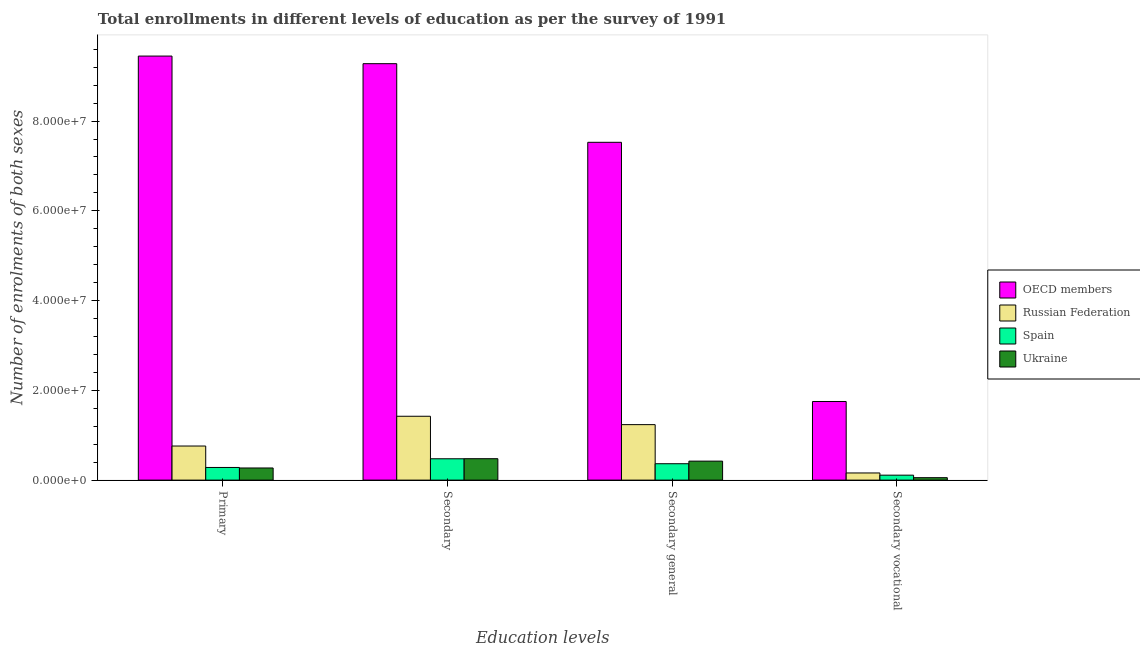Are the number of bars on each tick of the X-axis equal?
Make the answer very short. Yes. What is the label of the 3rd group of bars from the left?
Provide a short and direct response. Secondary general. What is the number of enrolments in secondary education in Ukraine?
Ensure brevity in your answer.  4.77e+06. Across all countries, what is the maximum number of enrolments in secondary general education?
Your answer should be very brief. 7.53e+07. Across all countries, what is the minimum number of enrolments in primary education?
Give a very brief answer. 2.70e+06. What is the total number of enrolments in primary education in the graph?
Make the answer very short. 1.08e+08. What is the difference between the number of enrolments in secondary education in Spain and that in Ukraine?
Your answer should be very brief. -1.84e+04. What is the difference between the number of enrolments in secondary education in Spain and the number of enrolments in secondary vocational education in Russian Federation?
Give a very brief answer. 3.16e+06. What is the average number of enrolments in secondary vocational education per country?
Provide a succinct answer. 5.19e+06. What is the difference between the number of enrolments in secondary general education and number of enrolments in secondary education in Russian Federation?
Your response must be concise. -1.87e+06. What is the ratio of the number of enrolments in secondary education in Ukraine to that in OECD members?
Your response must be concise. 0.05. Is the number of enrolments in primary education in Russian Federation less than that in OECD members?
Ensure brevity in your answer.  Yes. What is the difference between the highest and the second highest number of enrolments in secondary vocational education?
Your response must be concise. 1.59e+07. What is the difference between the highest and the lowest number of enrolments in secondary general education?
Ensure brevity in your answer.  7.16e+07. Is it the case that in every country, the sum of the number of enrolments in secondary general education and number of enrolments in secondary vocational education is greater than the sum of number of enrolments in secondary education and number of enrolments in primary education?
Offer a terse response. No. What does the 3rd bar from the left in Secondary general represents?
Offer a terse response. Spain. What does the 3rd bar from the right in Secondary vocational represents?
Keep it short and to the point. Russian Federation. Is it the case that in every country, the sum of the number of enrolments in primary education and number of enrolments in secondary education is greater than the number of enrolments in secondary general education?
Your answer should be very brief. Yes. How many bars are there?
Make the answer very short. 16. Are all the bars in the graph horizontal?
Give a very brief answer. No. How many countries are there in the graph?
Your answer should be compact. 4. What is the difference between two consecutive major ticks on the Y-axis?
Your answer should be compact. 2.00e+07. Are the values on the major ticks of Y-axis written in scientific E-notation?
Ensure brevity in your answer.  Yes. How are the legend labels stacked?
Offer a very short reply. Vertical. What is the title of the graph?
Your response must be concise. Total enrollments in different levels of education as per the survey of 1991. What is the label or title of the X-axis?
Your answer should be compact. Education levels. What is the label or title of the Y-axis?
Ensure brevity in your answer.  Number of enrolments of both sexes. What is the Number of enrolments of both sexes of OECD members in Primary?
Give a very brief answer. 9.45e+07. What is the Number of enrolments of both sexes of Russian Federation in Primary?
Make the answer very short. 7.60e+06. What is the Number of enrolments of both sexes in Spain in Primary?
Your response must be concise. 2.82e+06. What is the Number of enrolments of both sexes in Ukraine in Primary?
Give a very brief answer. 2.70e+06. What is the Number of enrolments of both sexes in OECD members in Secondary?
Give a very brief answer. 9.28e+07. What is the Number of enrolments of both sexes in Russian Federation in Secondary?
Offer a very short reply. 1.42e+07. What is the Number of enrolments of both sexes of Spain in Secondary?
Your response must be concise. 4.76e+06. What is the Number of enrolments of both sexes of Ukraine in Secondary?
Make the answer very short. 4.77e+06. What is the Number of enrolments of both sexes of OECD members in Secondary general?
Ensure brevity in your answer.  7.53e+07. What is the Number of enrolments of both sexes of Russian Federation in Secondary general?
Offer a terse response. 1.24e+07. What is the Number of enrolments of both sexes in Spain in Secondary general?
Your answer should be compact. 3.65e+06. What is the Number of enrolments of both sexes in Ukraine in Secondary general?
Ensure brevity in your answer.  4.23e+06. What is the Number of enrolments of both sexes of OECD members in Secondary vocational?
Your answer should be very brief. 1.75e+07. What is the Number of enrolments of both sexes in Russian Federation in Secondary vocational?
Provide a succinct answer. 1.59e+06. What is the Number of enrolments of both sexes in Spain in Secondary vocational?
Your answer should be very brief. 1.10e+06. What is the Number of enrolments of both sexes of Ukraine in Secondary vocational?
Offer a terse response. 5.44e+05. Across all Education levels, what is the maximum Number of enrolments of both sexes in OECD members?
Provide a short and direct response. 9.45e+07. Across all Education levels, what is the maximum Number of enrolments of both sexes of Russian Federation?
Provide a short and direct response. 1.42e+07. Across all Education levels, what is the maximum Number of enrolments of both sexes of Spain?
Give a very brief answer. 4.76e+06. Across all Education levels, what is the maximum Number of enrolments of both sexes in Ukraine?
Make the answer very short. 4.77e+06. Across all Education levels, what is the minimum Number of enrolments of both sexes in OECD members?
Give a very brief answer. 1.75e+07. Across all Education levels, what is the minimum Number of enrolments of both sexes of Russian Federation?
Provide a succinct answer. 1.59e+06. Across all Education levels, what is the minimum Number of enrolments of both sexes in Spain?
Provide a short and direct response. 1.10e+06. Across all Education levels, what is the minimum Number of enrolments of both sexes in Ukraine?
Make the answer very short. 5.44e+05. What is the total Number of enrolments of both sexes of OECD members in the graph?
Your answer should be compact. 2.80e+08. What is the total Number of enrolments of both sexes in Russian Federation in the graph?
Your answer should be compact. 3.58e+07. What is the total Number of enrolments of both sexes in Spain in the graph?
Offer a very short reply. 1.23e+07. What is the total Number of enrolments of both sexes in Ukraine in the graph?
Give a very brief answer. 1.23e+07. What is the difference between the Number of enrolments of both sexes in OECD members in Primary and that in Secondary?
Provide a succinct answer. 1.69e+06. What is the difference between the Number of enrolments of both sexes of Russian Federation in Primary and that in Secondary?
Give a very brief answer. -6.63e+06. What is the difference between the Number of enrolments of both sexes in Spain in Primary and that in Secondary?
Provide a short and direct response. -1.93e+06. What is the difference between the Number of enrolments of both sexes in Ukraine in Primary and that in Secondary?
Offer a very short reply. -2.07e+06. What is the difference between the Number of enrolments of both sexes in OECD members in Primary and that in Secondary general?
Provide a succinct answer. 1.92e+07. What is the difference between the Number of enrolments of both sexes in Russian Federation in Primary and that in Secondary general?
Offer a very short reply. -4.77e+06. What is the difference between the Number of enrolments of both sexes of Spain in Primary and that in Secondary general?
Provide a succinct answer. -8.33e+05. What is the difference between the Number of enrolments of both sexes in Ukraine in Primary and that in Secondary general?
Ensure brevity in your answer.  -1.53e+06. What is the difference between the Number of enrolments of both sexes in OECD members in Primary and that in Secondary vocational?
Keep it short and to the point. 7.70e+07. What is the difference between the Number of enrolments of both sexes in Russian Federation in Primary and that in Secondary vocational?
Provide a succinct answer. 6.00e+06. What is the difference between the Number of enrolments of both sexes in Spain in Primary and that in Secondary vocational?
Give a very brief answer. 1.72e+06. What is the difference between the Number of enrolments of both sexes in Ukraine in Primary and that in Secondary vocational?
Make the answer very short. 2.16e+06. What is the difference between the Number of enrolments of both sexes in OECD members in Secondary and that in Secondary general?
Your answer should be compact. 1.75e+07. What is the difference between the Number of enrolments of both sexes in Russian Federation in Secondary and that in Secondary general?
Offer a very short reply. 1.87e+06. What is the difference between the Number of enrolments of both sexes of Spain in Secondary and that in Secondary general?
Your answer should be compact. 1.10e+06. What is the difference between the Number of enrolments of both sexes of Ukraine in Secondary and that in Secondary general?
Make the answer very short. 5.44e+05. What is the difference between the Number of enrolments of both sexes of OECD members in Secondary and that in Secondary vocational?
Make the answer very short. 7.53e+07. What is the difference between the Number of enrolments of both sexes in Russian Federation in Secondary and that in Secondary vocational?
Provide a short and direct response. 1.26e+07. What is the difference between the Number of enrolments of both sexes in Spain in Secondary and that in Secondary vocational?
Ensure brevity in your answer.  3.65e+06. What is the difference between the Number of enrolments of both sexes in Ukraine in Secondary and that in Secondary vocational?
Offer a terse response. 4.23e+06. What is the difference between the Number of enrolments of both sexes in OECD members in Secondary general and that in Secondary vocational?
Ensure brevity in your answer.  5.77e+07. What is the difference between the Number of enrolments of both sexes of Russian Federation in Secondary general and that in Secondary vocational?
Keep it short and to the point. 1.08e+07. What is the difference between the Number of enrolments of both sexes in Spain in Secondary general and that in Secondary vocational?
Your response must be concise. 2.55e+06. What is the difference between the Number of enrolments of both sexes in Ukraine in Secondary general and that in Secondary vocational?
Give a very brief answer. 3.69e+06. What is the difference between the Number of enrolments of both sexes in OECD members in Primary and the Number of enrolments of both sexes in Russian Federation in Secondary?
Ensure brevity in your answer.  8.03e+07. What is the difference between the Number of enrolments of both sexes of OECD members in Primary and the Number of enrolments of both sexes of Spain in Secondary?
Your response must be concise. 8.97e+07. What is the difference between the Number of enrolments of both sexes of OECD members in Primary and the Number of enrolments of both sexes of Ukraine in Secondary?
Make the answer very short. 8.97e+07. What is the difference between the Number of enrolments of both sexes of Russian Federation in Primary and the Number of enrolments of both sexes of Spain in Secondary?
Offer a terse response. 2.84e+06. What is the difference between the Number of enrolments of both sexes in Russian Federation in Primary and the Number of enrolments of both sexes in Ukraine in Secondary?
Your response must be concise. 2.82e+06. What is the difference between the Number of enrolments of both sexes of Spain in Primary and the Number of enrolments of both sexes of Ukraine in Secondary?
Give a very brief answer. -1.95e+06. What is the difference between the Number of enrolments of both sexes in OECD members in Primary and the Number of enrolments of both sexes in Russian Federation in Secondary general?
Keep it short and to the point. 8.21e+07. What is the difference between the Number of enrolments of both sexes of OECD members in Primary and the Number of enrolments of both sexes of Spain in Secondary general?
Ensure brevity in your answer.  9.08e+07. What is the difference between the Number of enrolments of both sexes in OECD members in Primary and the Number of enrolments of both sexes in Ukraine in Secondary general?
Ensure brevity in your answer.  9.03e+07. What is the difference between the Number of enrolments of both sexes of Russian Federation in Primary and the Number of enrolments of both sexes of Spain in Secondary general?
Your answer should be very brief. 3.94e+06. What is the difference between the Number of enrolments of both sexes of Russian Federation in Primary and the Number of enrolments of both sexes of Ukraine in Secondary general?
Offer a very short reply. 3.37e+06. What is the difference between the Number of enrolments of both sexes of Spain in Primary and the Number of enrolments of both sexes of Ukraine in Secondary general?
Offer a very short reply. -1.41e+06. What is the difference between the Number of enrolments of both sexes in OECD members in Primary and the Number of enrolments of both sexes in Russian Federation in Secondary vocational?
Make the answer very short. 9.29e+07. What is the difference between the Number of enrolments of both sexes of OECD members in Primary and the Number of enrolments of both sexes of Spain in Secondary vocational?
Keep it short and to the point. 9.34e+07. What is the difference between the Number of enrolments of both sexes of OECD members in Primary and the Number of enrolments of both sexes of Ukraine in Secondary vocational?
Your answer should be very brief. 9.39e+07. What is the difference between the Number of enrolments of both sexes in Russian Federation in Primary and the Number of enrolments of both sexes in Spain in Secondary vocational?
Your answer should be very brief. 6.49e+06. What is the difference between the Number of enrolments of both sexes of Russian Federation in Primary and the Number of enrolments of both sexes of Ukraine in Secondary vocational?
Ensure brevity in your answer.  7.05e+06. What is the difference between the Number of enrolments of both sexes of Spain in Primary and the Number of enrolments of both sexes of Ukraine in Secondary vocational?
Provide a succinct answer. 2.28e+06. What is the difference between the Number of enrolments of both sexes in OECD members in Secondary and the Number of enrolments of both sexes in Russian Federation in Secondary general?
Provide a short and direct response. 8.04e+07. What is the difference between the Number of enrolments of both sexes in OECD members in Secondary and the Number of enrolments of both sexes in Spain in Secondary general?
Make the answer very short. 8.91e+07. What is the difference between the Number of enrolments of both sexes in OECD members in Secondary and the Number of enrolments of both sexes in Ukraine in Secondary general?
Offer a very short reply. 8.86e+07. What is the difference between the Number of enrolments of both sexes in Russian Federation in Secondary and the Number of enrolments of both sexes in Spain in Secondary general?
Your answer should be compact. 1.06e+07. What is the difference between the Number of enrolments of both sexes of Russian Federation in Secondary and the Number of enrolments of both sexes of Ukraine in Secondary general?
Provide a short and direct response. 1.00e+07. What is the difference between the Number of enrolments of both sexes in Spain in Secondary and the Number of enrolments of both sexes in Ukraine in Secondary general?
Give a very brief answer. 5.25e+05. What is the difference between the Number of enrolments of both sexes in OECD members in Secondary and the Number of enrolments of both sexes in Russian Federation in Secondary vocational?
Make the answer very short. 9.12e+07. What is the difference between the Number of enrolments of both sexes in OECD members in Secondary and the Number of enrolments of both sexes in Spain in Secondary vocational?
Keep it short and to the point. 9.17e+07. What is the difference between the Number of enrolments of both sexes of OECD members in Secondary and the Number of enrolments of both sexes of Ukraine in Secondary vocational?
Your response must be concise. 9.22e+07. What is the difference between the Number of enrolments of both sexes of Russian Federation in Secondary and the Number of enrolments of both sexes of Spain in Secondary vocational?
Give a very brief answer. 1.31e+07. What is the difference between the Number of enrolments of both sexes of Russian Federation in Secondary and the Number of enrolments of both sexes of Ukraine in Secondary vocational?
Provide a short and direct response. 1.37e+07. What is the difference between the Number of enrolments of both sexes of Spain in Secondary and the Number of enrolments of both sexes of Ukraine in Secondary vocational?
Offer a very short reply. 4.21e+06. What is the difference between the Number of enrolments of both sexes in OECD members in Secondary general and the Number of enrolments of both sexes in Russian Federation in Secondary vocational?
Offer a terse response. 7.37e+07. What is the difference between the Number of enrolments of both sexes in OECD members in Secondary general and the Number of enrolments of both sexes in Spain in Secondary vocational?
Ensure brevity in your answer.  7.42e+07. What is the difference between the Number of enrolments of both sexes of OECD members in Secondary general and the Number of enrolments of both sexes of Ukraine in Secondary vocational?
Provide a short and direct response. 7.47e+07. What is the difference between the Number of enrolments of both sexes in Russian Federation in Secondary general and the Number of enrolments of both sexes in Spain in Secondary vocational?
Your response must be concise. 1.13e+07. What is the difference between the Number of enrolments of both sexes of Russian Federation in Secondary general and the Number of enrolments of both sexes of Ukraine in Secondary vocational?
Make the answer very short. 1.18e+07. What is the difference between the Number of enrolments of both sexes in Spain in Secondary general and the Number of enrolments of both sexes in Ukraine in Secondary vocational?
Ensure brevity in your answer.  3.11e+06. What is the average Number of enrolments of both sexes in OECD members per Education levels?
Offer a very short reply. 7.00e+07. What is the average Number of enrolments of both sexes of Russian Federation per Education levels?
Offer a very short reply. 8.95e+06. What is the average Number of enrolments of both sexes in Spain per Education levels?
Offer a very short reply. 3.08e+06. What is the average Number of enrolments of both sexes in Ukraine per Education levels?
Offer a very short reply. 3.06e+06. What is the difference between the Number of enrolments of both sexes of OECD members and Number of enrolments of both sexes of Russian Federation in Primary?
Keep it short and to the point. 8.69e+07. What is the difference between the Number of enrolments of both sexes in OECD members and Number of enrolments of both sexes in Spain in Primary?
Keep it short and to the point. 9.17e+07. What is the difference between the Number of enrolments of both sexes of OECD members and Number of enrolments of both sexes of Ukraine in Primary?
Your answer should be compact. 9.18e+07. What is the difference between the Number of enrolments of both sexes in Russian Federation and Number of enrolments of both sexes in Spain in Primary?
Your answer should be very brief. 4.78e+06. What is the difference between the Number of enrolments of both sexes of Russian Federation and Number of enrolments of both sexes of Ukraine in Primary?
Offer a terse response. 4.89e+06. What is the difference between the Number of enrolments of both sexes of Spain and Number of enrolments of both sexes of Ukraine in Primary?
Your answer should be compact. 1.17e+05. What is the difference between the Number of enrolments of both sexes in OECD members and Number of enrolments of both sexes in Russian Federation in Secondary?
Provide a succinct answer. 7.86e+07. What is the difference between the Number of enrolments of both sexes in OECD members and Number of enrolments of both sexes in Spain in Secondary?
Your answer should be very brief. 8.80e+07. What is the difference between the Number of enrolments of both sexes of OECD members and Number of enrolments of both sexes of Ukraine in Secondary?
Your answer should be very brief. 8.80e+07. What is the difference between the Number of enrolments of both sexes in Russian Federation and Number of enrolments of both sexes in Spain in Secondary?
Your answer should be very brief. 9.47e+06. What is the difference between the Number of enrolments of both sexes of Russian Federation and Number of enrolments of both sexes of Ukraine in Secondary?
Provide a succinct answer. 9.46e+06. What is the difference between the Number of enrolments of both sexes of Spain and Number of enrolments of both sexes of Ukraine in Secondary?
Your answer should be very brief. -1.84e+04. What is the difference between the Number of enrolments of both sexes in OECD members and Number of enrolments of both sexes in Russian Federation in Secondary general?
Your response must be concise. 6.29e+07. What is the difference between the Number of enrolments of both sexes of OECD members and Number of enrolments of both sexes of Spain in Secondary general?
Give a very brief answer. 7.16e+07. What is the difference between the Number of enrolments of both sexes of OECD members and Number of enrolments of both sexes of Ukraine in Secondary general?
Provide a short and direct response. 7.10e+07. What is the difference between the Number of enrolments of both sexes in Russian Federation and Number of enrolments of both sexes in Spain in Secondary general?
Provide a succinct answer. 8.71e+06. What is the difference between the Number of enrolments of both sexes of Russian Federation and Number of enrolments of both sexes of Ukraine in Secondary general?
Keep it short and to the point. 8.13e+06. What is the difference between the Number of enrolments of both sexes in Spain and Number of enrolments of both sexes in Ukraine in Secondary general?
Offer a terse response. -5.77e+05. What is the difference between the Number of enrolments of both sexes of OECD members and Number of enrolments of both sexes of Russian Federation in Secondary vocational?
Your answer should be very brief. 1.59e+07. What is the difference between the Number of enrolments of both sexes in OECD members and Number of enrolments of both sexes in Spain in Secondary vocational?
Provide a succinct answer. 1.64e+07. What is the difference between the Number of enrolments of both sexes in OECD members and Number of enrolments of both sexes in Ukraine in Secondary vocational?
Give a very brief answer. 1.70e+07. What is the difference between the Number of enrolments of both sexes of Russian Federation and Number of enrolments of both sexes of Spain in Secondary vocational?
Your answer should be compact. 4.91e+05. What is the difference between the Number of enrolments of both sexes of Russian Federation and Number of enrolments of both sexes of Ukraine in Secondary vocational?
Make the answer very short. 1.05e+06. What is the difference between the Number of enrolments of both sexes of Spain and Number of enrolments of both sexes of Ukraine in Secondary vocational?
Your answer should be compact. 5.58e+05. What is the ratio of the Number of enrolments of both sexes in OECD members in Primary to that in Secondary?
Your answer should be very brief. 1.02. What is the ratio of the Number of enrolments of both sexes of Russian Federation in Primary to that in Secondary?
Keep it short and to the point. 0.53. What is the ratio of the Number of enrolments of both sexes of Spain in Primary to that in Secondary?
Offer a very short reply. 0.59. What is the ratio of the Number of enrolments of both sexes in Ukraine in Primary to that in Secondary?
Make the answer very short. 0.57. What is the ratio of the Number of enrolments of both sexes of OECD members in Primary to that in Secondary general?
Offer a terse response. 1.26. What is the ratio of the Number of enrolments of both sexes in Russian Federation in Primary to that in Secondary general?
Keep it short and to the point. 0.61. What is the ratio of the Number of enrolments of both sexes of Spain in Primary to that in Secondary general?
Provide a short and direct response. 0.77. What is the ratio of the Number of enrolments of both sexes of Ukraine in Primary to that in Secondary general?
Make the answer very short. 0.64. What is the ratio of the Number of enrolments of both sexes in OECD members in Primary to that in Secondary vocational?
Your answer should be compact. 5.39. What is the ratio of the Number of enrolments of both sexes of Russian Federation in Primary to that in Secondary vocational?
Make the answer very short. 4.77. What is the ratio of the Number of enrolments of both sexes of Spain in Primary to that in Secondary vocational?
Provide a short and direct response. 2.56. What is the ratio of the Number of enrolments of both sexes in Ukraine in Primary to that in Secondary vocational?
Ensure brevity in your answer.  4.97. What is the ratio of the Number of enrolments of both sexes in OECD members in Secondary to that in Secondary general?
Offer a terse response. 1.23. What is the ratio of the Number of enrolments of both sexes in Russian Federation in Secondary to that in Secondary general?
Keep it short and to the point. 1.15. What is the ratio of the Number of enrolments of both sexes in Spain in Secondary to that in Secondary general?
Give a very brief answer. 1.3. What is the ratio of the Number of enrolments of both sexes of Ukraine in Secondary to that in Secondary general?
Provide a succinct answer. 1.13. What is the ratio of the Number of enrolments of both sexes of OECD members in Secondary to that in Secondary vocational?
Your answer should be compact. 5.3. What is the ratio of the Number of enrolments of both sexes in Russian Federation in Secondary to that in Secondary vocational?
Make the answer very short. 8.93. What is the ratio of the Number of enrolments of both sexes in Spain in Secondary to that in Secondary vocational?
Provide a succinct answer. 4.32. What is the ratio of the Number of enrolments of both sexes of Ukraine in Secondary to that in Secondary vocational?
Make the answer very short. 8.78. What is the ratio of the Number of enrolments of both sexes in OECD members in Secondary general to that in Secondary vocational?
Your answer should be very brief. 4.3. What is the ratio of the Number of enrolments of both sexes of Russian Federation in Secondary general to that in Secondary vocational?
Keep it short and to the point. 7.76. What is the ratio of the Number of enrolments of both sexes of Spain in Secondary general to that in Secondary vocational?
Provide a succinct answer. 3.32. What is the ratio of the Number of enrolments of both sexes in Ukraine in Secondary general to that in Secondary vocational?
Offer a very short reply. 7.78. What is the difference between the highest and the second highest Number of enrolments of both sexes of OECD members?
Offer a terse response. 1.69e+06. What is the difference between the highest and the second highest Number of enrolments of both sexes in Russian Federation?
Your response must be concise. 1.87e+06. What is the difference between the highest and the second highest Number of enrolments of both sexes in Spain?
Your response must be concise. 1.10e+06. What is the difference between the highest and the second highest Number of enrolments of both sexes in Ukraine?
Offer a terse response. 5.44e+05. What is the difference between the highest and the lowest Number of enrolments of both sexes in OECD members?
Give a very brief answer. 7.70e+07. What is the difference between the highest and the lowest Number of enrolments of both sexes in Russian Federation?
Make the answer very short. 1.26e+07. What is the difference between the highest and the lowest Number of enrolments of both sexes in Spain?
Give a very brief answer. 3.65e+06. What is the difference between the highest and the lowest Number of enrolments of both sexes in Ukraine?
Offer a very short reply. 4.23e+06. 